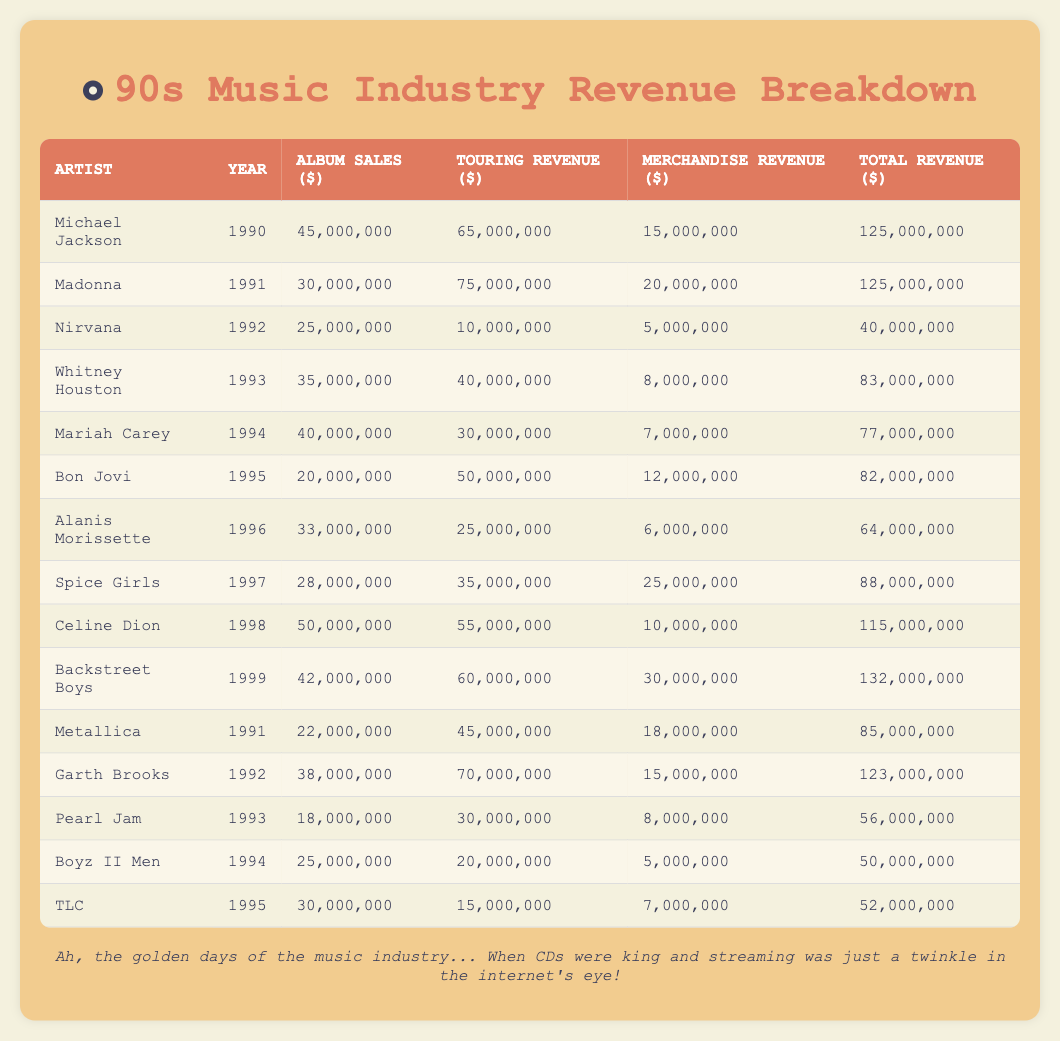What was the total revenue for Mariah Carey in 1994? From the table, we see that Mariah Carey's total revenue in 1994 is listed as 77,000,000 dollars.
Answer: 77,000,000 Who generated more revenue from touring, Bon Jovi in 1995 or Whitney Houston in 1993? Bon Jovi's touring revenue in 1995 is 50,000,000 dollars, while Whitney Houston's touring revenue in 1993 is 40,000,000 dollars. Comparing the two values, Bon Jovi earned more from touring.
Answer: Bon Jovi What is the average merchandise revenue of the listed artists across all years? To find the average, we first sum the merchandise revenues: 15,000,000 + 20,000,000 + 5,000,000 + 8,000,000 + 7,000,000 + 12,000,000 + 6,000,000 + 25,000,000 + 10,000,000 + 30,000,000 + 18,000,000 + 15,000,000 + 8,000,000 + 5,000,000 + 7,000,000 = 10,000,000. Next, we divide by the total number of artists (15), which gives us 180,000,000 / 15 = 12,000,000.
Answer: 12,000,000 Did Celine Dion earn more from album sales than the Backstreet Boys in 1999? Celine Dion's album sales in 1998 are 50,000,000 dollars, while the Backstreet Boys' album sales in 1999 are 42,000,000 dollars. Since 50,000,000 is greater than 42,000,000, Celine Dion earned more from album sales.
Answer: Yes Which artist had the highest total revenue, and what was the amount? The table indicates that the Backstreet Boys in 1999 had the highest total revenue at 132,000,000 dollars, making them the artist with the highest revenue.
Answer: Backstreet Boys, 132,000,000 Which year had the highest album sales, and how much was it? To find the highest album sales, we look through each artist's album sales in their respective years: 45,000,000 (Michael Jackson, 1990), 30,000,000 (Madonna, 1991), 25,000,000 (Nirvana, 1992), 35,000,000 (Whitney Houston, 1993), 40,000,000 (Mariah Carey, 1994), 20,000,000 (Bon Jovi, 1995), 33,000,000 (Alanis Morissette, 1996), 28,000,000 (Spice Girls, 1997), 50,000,000 (Celine Dion, 1998), and 42,000,000 (Backstreet Boys, 1999). The highest is Celine Dion with 50,000,000 in 1998.
Answer: 1998, 50,000,000 